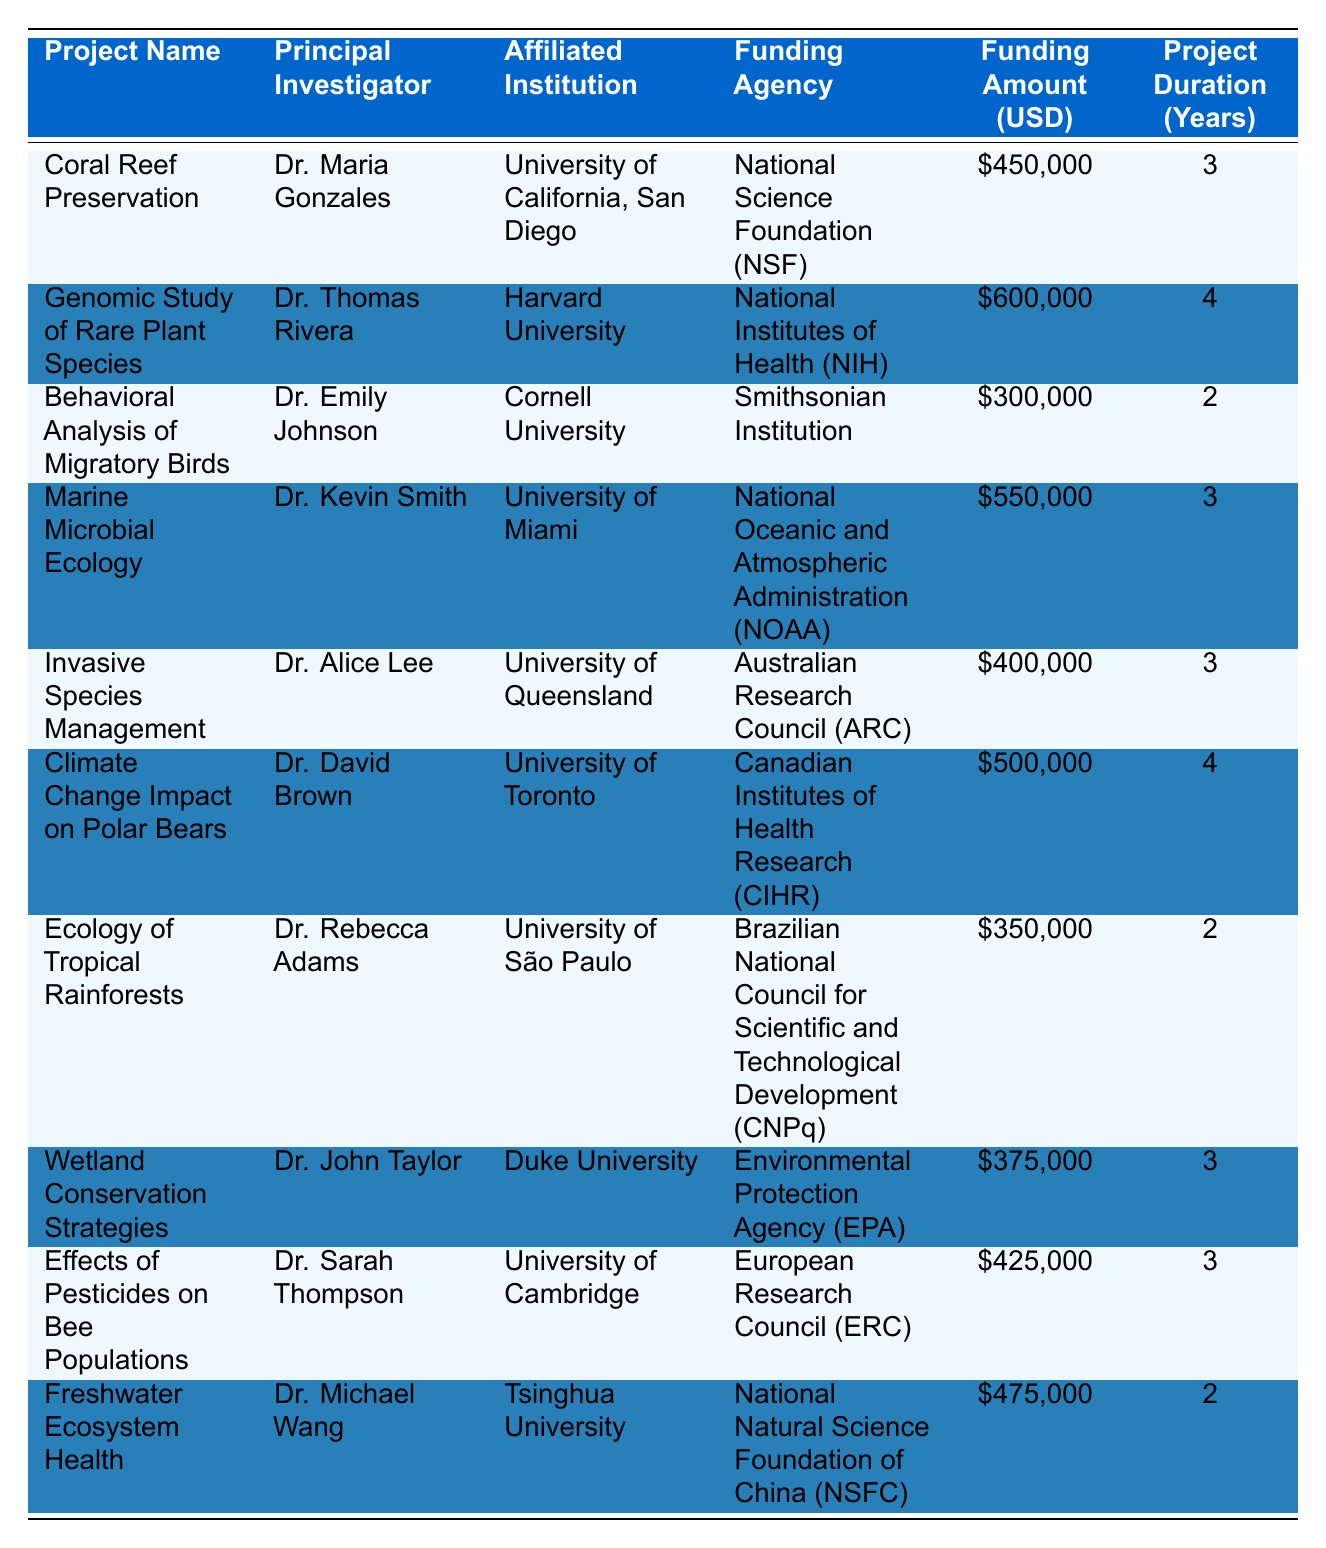What is the highest funding amount received for a project? The table shows various projects along with their funding amounts. Scanning through the "Funding Amount (USD)" column, the highest value is 600,000 for the project "Genomic Study of Rare Plant Species" led by Dr. Thomas Rivera.
Answer: 600000 Which institution is affiliated with the "Climate Change Impact on Polar Bears" project? The "Affiliated Institution" column reveals the institution associated with each project. For "Climate Change Impact on Polar Bears," Dr. David Brown is affiliated with the University of Toronto.
Answer: University of Toronto How many projects received funding for 3 years? We can count the number of rows where the "Project Duration (Years)" is 3. Checking the table, there are 5 projects with this duration: "Coral Reef Preservation," "Marine Microbial Ecology," "Invasive Species Management," "Wetland Conservation Strategies," and "Effects of Pesticides on Bee Populations."
Answer: 5 Is the total funding amount for projects under NIH greater than that under NOAA? First, we add the funding amounts for projects under NIH: 600,000 (Genomic Study of Rare Plant Species). Under NOAA: 550,000 (Marine Microbial Ecology). Since 600,000 is greater than 550,000, the answer is yes.
Answer: Yes What is the average funding amount for projects lasting 2 years? The projects lasting 2 years are "Behavioral Analysis of Migratory Birds," "Ecology of Tropical Rainforests," and "Freshwater Ecosystem Health" with funding amounts of 300,000, 350,000, and 475,000 respectively. Adding these gives 300,000 + 350,000 + 475,000 = 1,125,000. Dividing by the number of projects (3) gives an average of 1,125,000 / 3 = 375,000.
Answer: 375000 Which funding agency provided the least funding? Reviewing the "Funding Amount (USD)" column for each funding agency, we find that the least funding of 300,000 was provided by the Smithsonian Institution for the "Behavioral Analysis of Migratory Birds."
Answer: Smithsonian Institution 